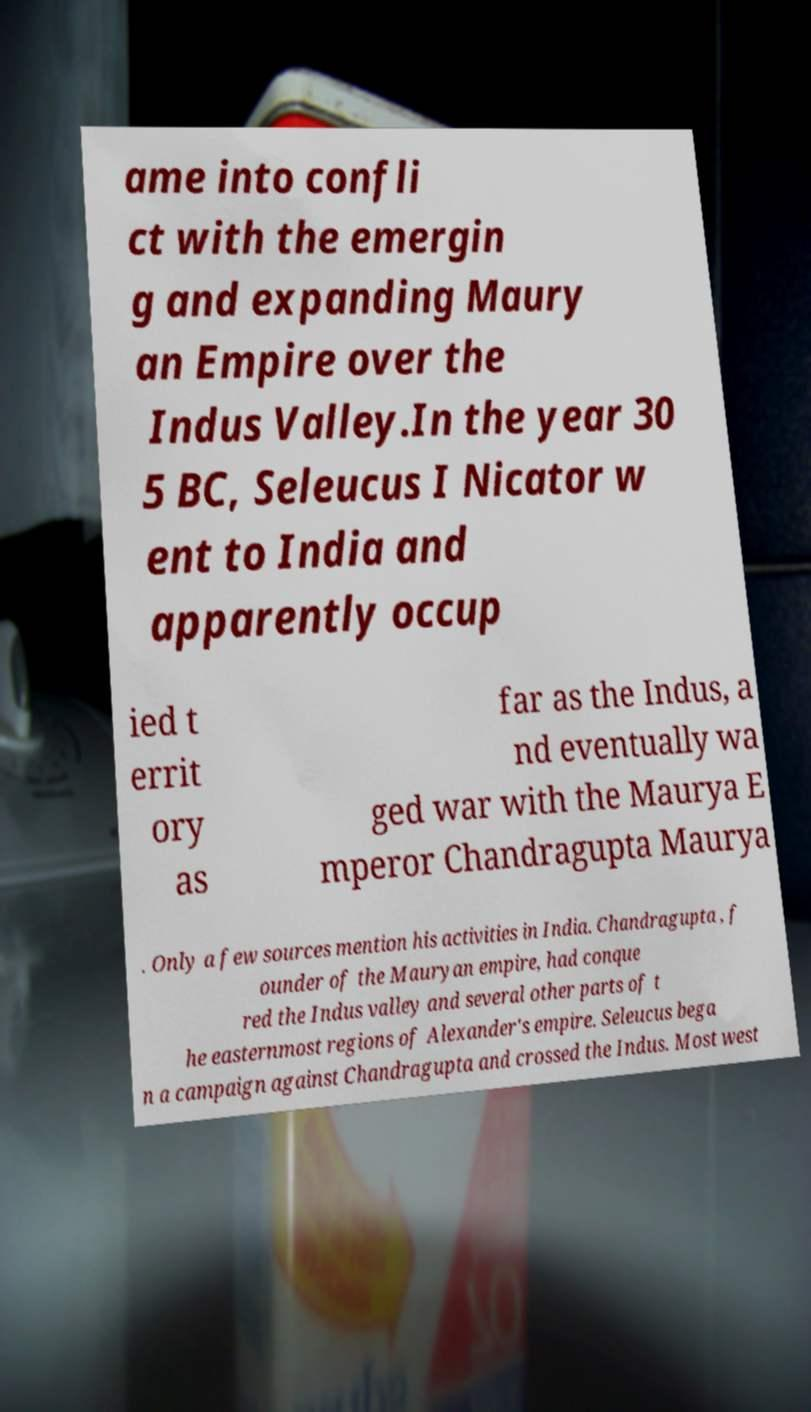Can you read and provide the text displayed in the image?This photo seems to have some interesting text. Can you extract and type it out for me? ame into confli ct with the emergin g and expanding Maury an Empire over the Indus Valley.In the year 30 5 BC, Seleucus I Nicator w ent to India and apparently occup ied t errit ory as far as the Indus, a nd eventually wa ged war with the Maurya E mperor Chandragupta Maurya . Only a few sources mention his activities in India. Chandragupta , f ounder of the Mauryan empire, had conque red the Indus valley and several other parts of t he easternmost regions of Alexander's empire. Seleucus bega n a campaign against Chandragupta and crossed the Indus. Most west 